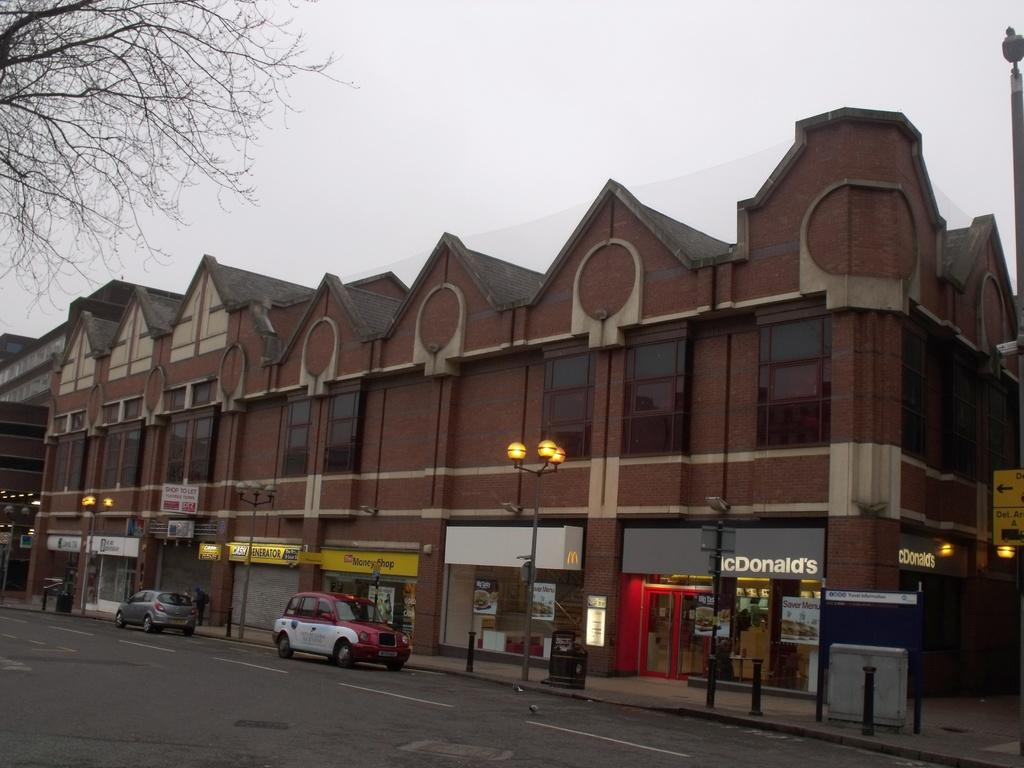<image>
Write a terse but informative summary of the picture. A brick commercial building containing many small shops including a Mcdonalds. 